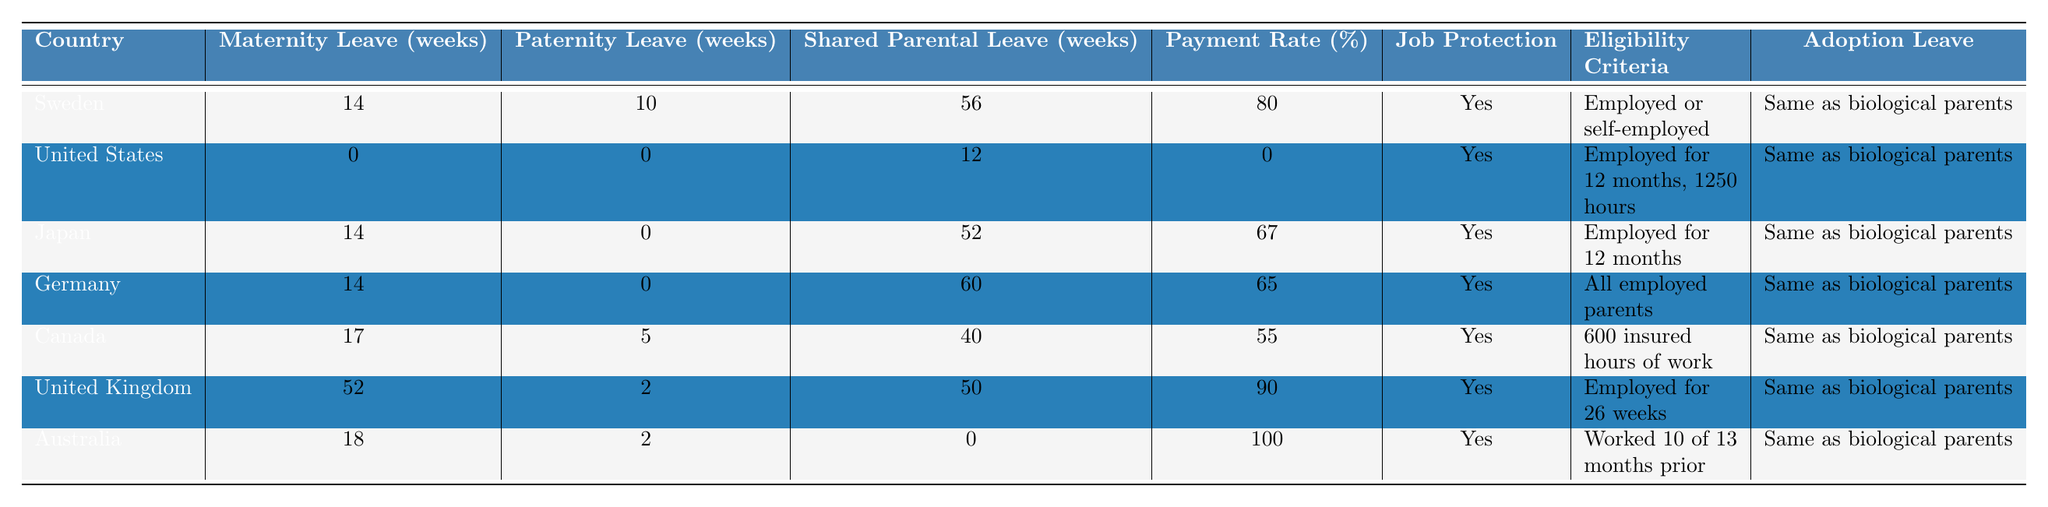What is the maximum maternity leave offered among the countries listed? By examining the "Maternity Leave (weeks)" column, the country with the highest value is the United Kingdom, which offers 52 weeks of maternity leave.
Answer: 52 weeks Which country provides the least amount of paternity leave? The table indicates that the United States and Japan both provide 0 weeks of paternity leave.
Answer: United States and Japan What is the payment rate for shared parental leave in Sweden? Referring to the "Payment Rate (%)" column under Sweden, the value is 80%.
Answer: 80% Is job protection guaranteed in Germany? Looking at the "Job Protection" column for Germany, it states "Yes," indicating job protection is guaranteed.
Answer: Yes How many weeks of shared parental leave do Canada and Australia provide combined? Canada offers 40 weeks and Australia offers 0 weeks for shared parental leave. Adding these values together results in 40 + 0 = 40 weeks.
Answer: 40 weeks Which country has the highest payment rate and what is that rate? Upon reviewing the "Payment Rate (%)" column, Australia has the highest payment rate at 100%.
Answer: 100% What is the eligibility criteria for shared parental leave in Japan? The table shows that the eligibility criteria for Japan is "Employed for 12 months."
Answer: Employed for 12 months Are all countries listed providing adoption leave the same as biological parents? By checking the "Adoption Leave" column for all countries, it consistently states "Same as biological parents," confirming this fact across the table.
Answer: Yes How many weeks of total parental leave can parents take in Germany, combining maternity and shared parental leave? Germany offers 14 weeks of maternity leave and 60 weeks of shared parental leave. Summing these amounts gives 14 + 60 = 74 weeks.
Answer: 74 weeks Which country provides no shared parental leave and what is its maternity leave policy? Australia offers 0 weeks of shared parental leave and provides 18 weeks of maternity leave.
Answer: Australia; 18 weeks maternity leave 